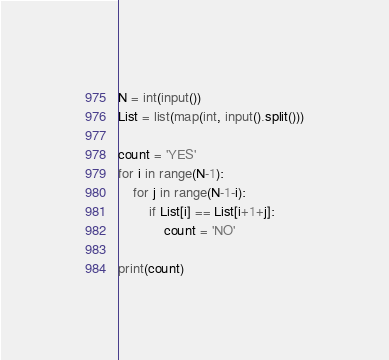<code> <loc_0><loc_0><loc_500><loc_500><_Python_>N = int(input())
List = list(map(int, input().split()))

count = 'YES'
for i in range(N-1):
    for j in range(N-1-i):
        if List[i] == List[i+1+j]:
            count = 'NO'

print(count)</code> 